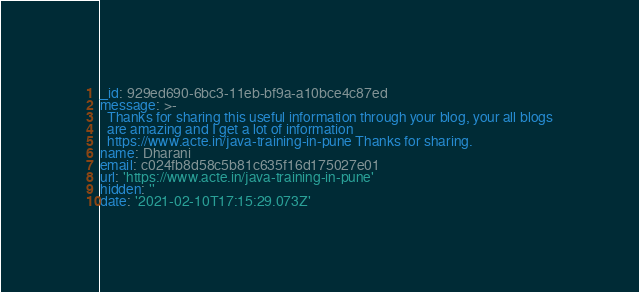Convert code to text. <code><loc_0><loc_0><loc_500><loc_500><_YAML_>_id: 929ed690-6bc3-11eb-bf9a-a10bce4c87ed
message: >-
  Thanks for sharing this useful information through your blog, your all blogs
  are amazing and I get a lot of information
  https://www.acte.in/java-training-in-pune Thanks for sharing.
name: Dharani
email: c024fb8d58c5b81c635f16d175027e01
url: 'https://www.acte.in/java-training-in-pune'
hidden: ''
date: '2021-02-10T17:15:29.073Z'
</code> 